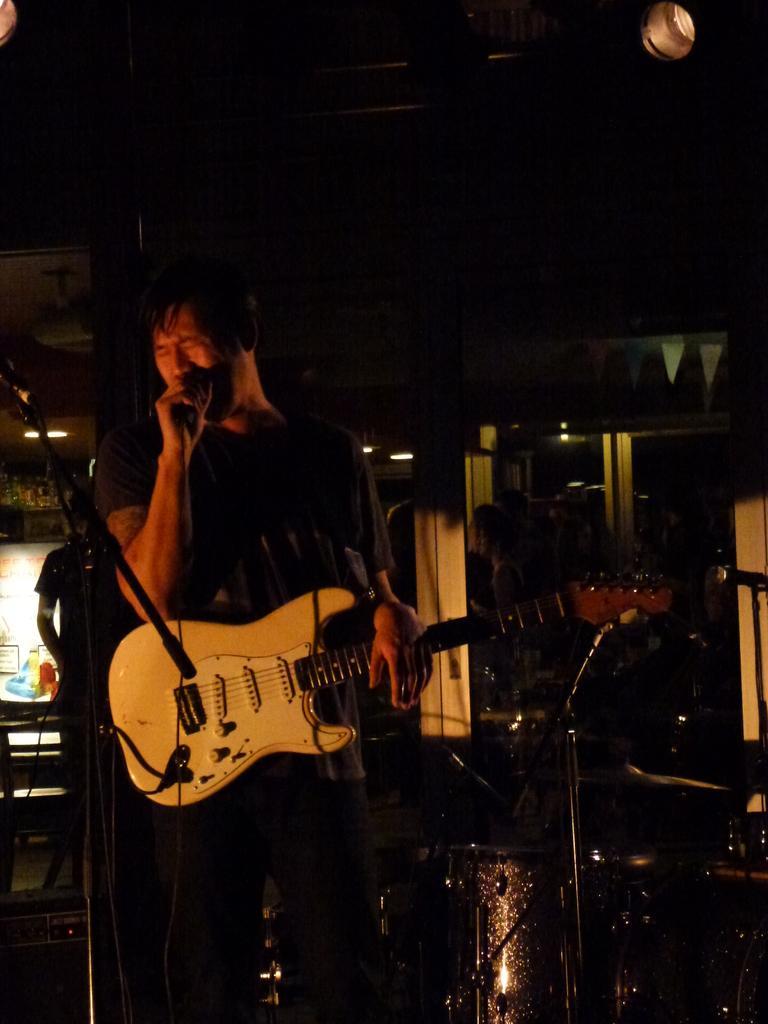How would you summarize this image in a sentence or two? A black shirt guy who is singing with a mic placed in front of him and playing a guitar. In the background we observe many people and there are few musical instruments beside him. There is also a light to the roof. The picture is clicked inside a restaurant. 